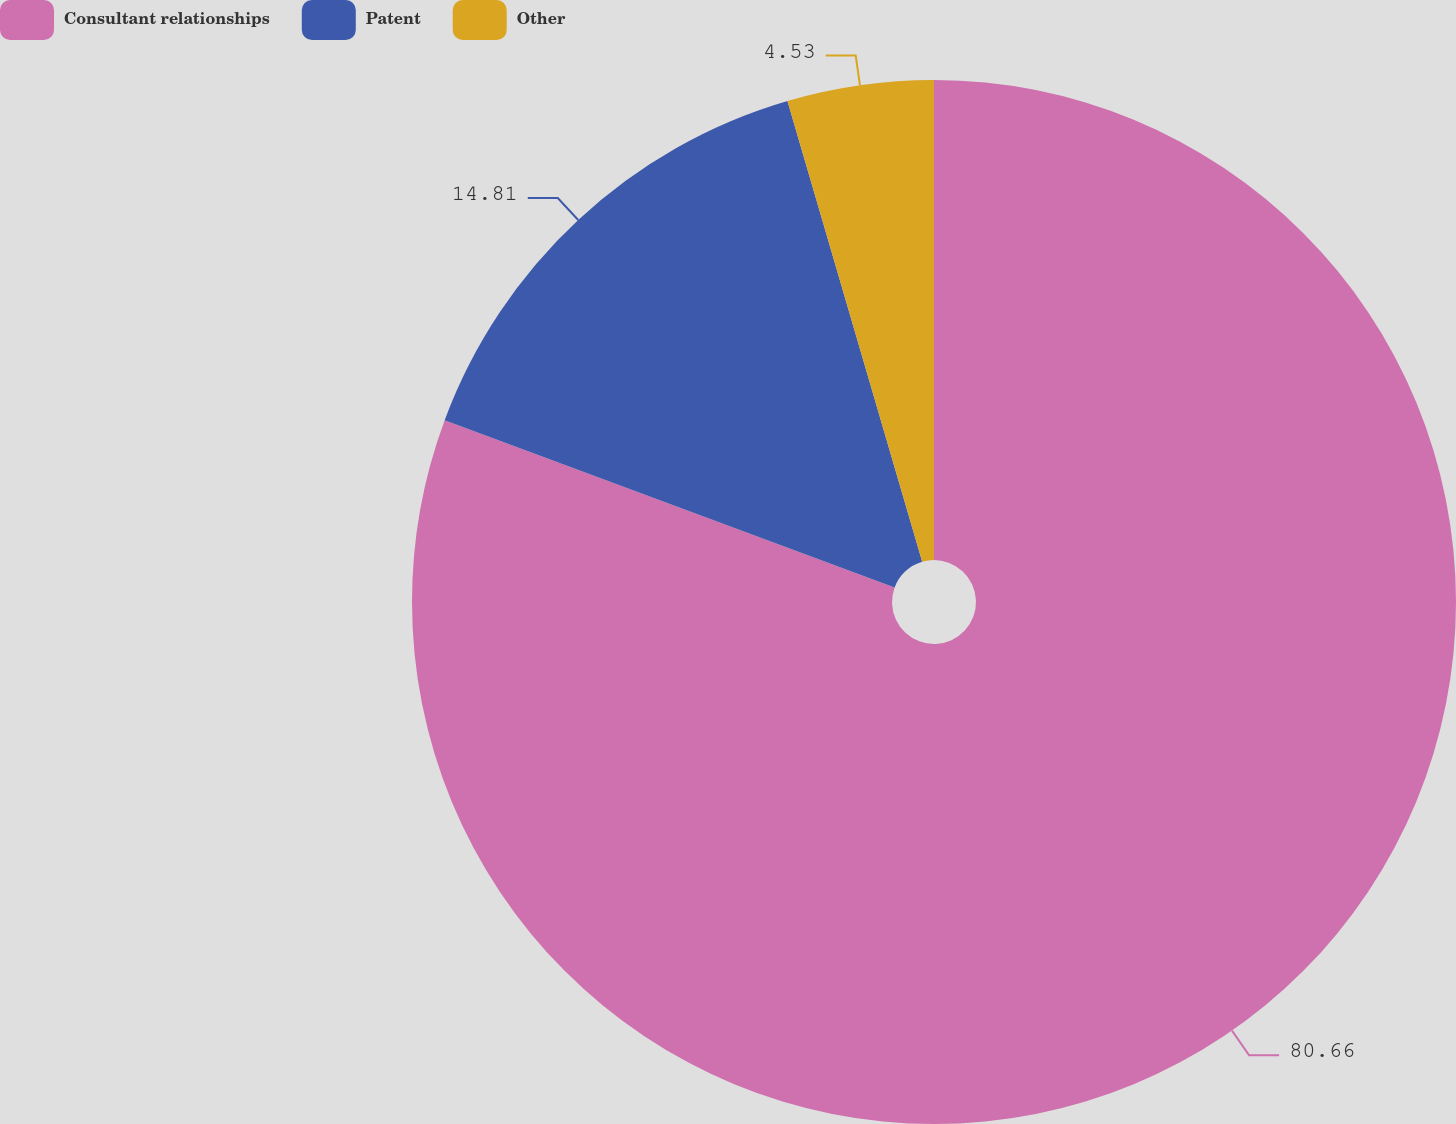Convert chart to OTSL. <chart><loc_0><loc_0><loc_500><loc_500><pie_chart><fcel>Consultant relationships<fcel>Patent<fcel>Other<nl><fcel>80.66%<fcel>14.81%<fcel>4.53%<nl></chart> 